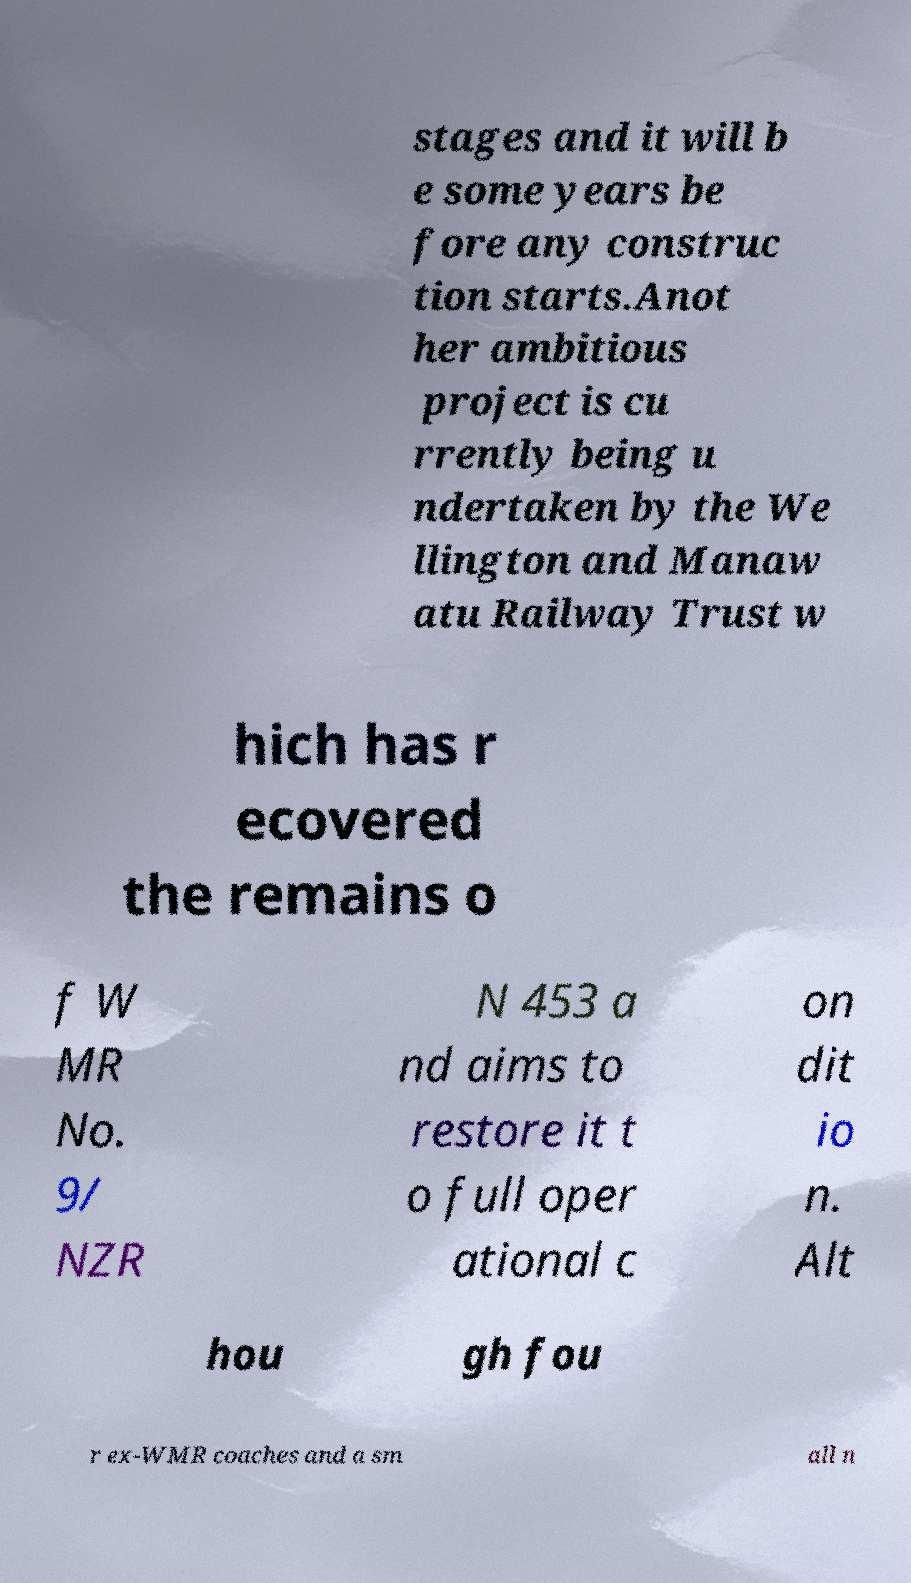Could you assist in decoding the text presented in this image and type it out clearly? stages and it will b e some years be fore any construc tion starts.Anot her ambitious project is cu rrently being u ndertaken by the We llington and Manaw atu Railway Trust w hich has r ecovered the remains o f W MR No. 9/ NZR N 453 a nd aims to restore it t o full oper ational c on dit io n. Alt hou gh fou r ex-WMR coaches and a sm all n 